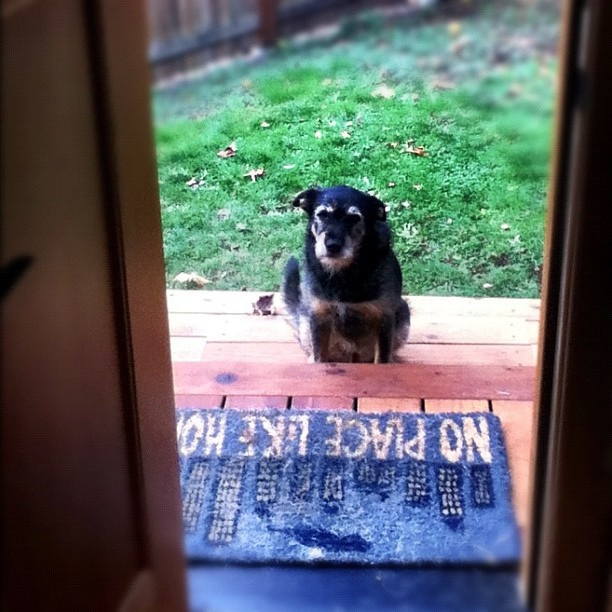Describe the objects in this image and their specific colors. I can see a dog in black, gray, and navy tones in this image. 